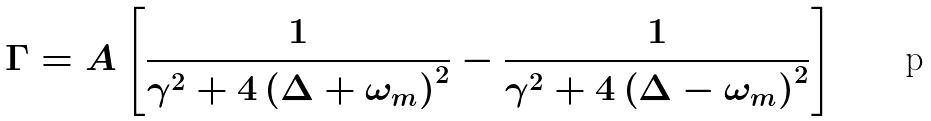Convert formula to latex. <formula><loc_0><loc_0><loc_500><loc_500>\Gamma = A \left [ \frac { 1 } { \gamma ^ { 2 } + 4 \left ( \Delta + \omega _ { m } \right ) ^ { 2 } } - \frac { 1 } { \gamma ^ { 2 } + 4 \left ( \Delta - \omega _ { m } \right ) ^ { 2 } } \right ]</formula> 